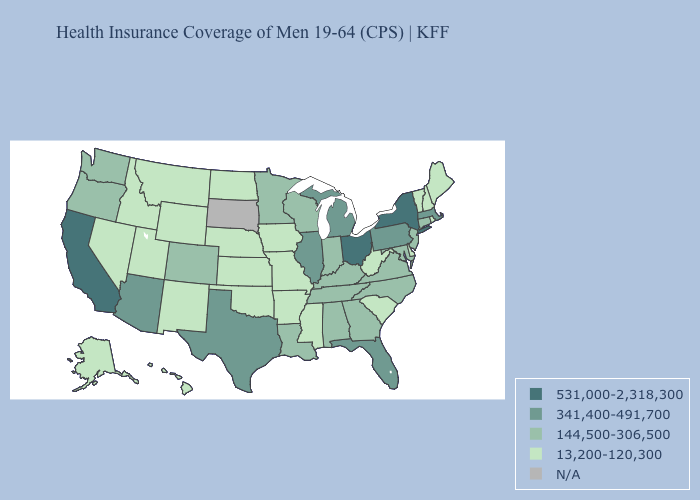What is the value of Illinois?
Write a very short answer. 341,400-491,700. Does Michigan have the lowest value in the MidWest?
Give a very brief answer. No. What is the value of Tennessee?
Write a very short answer. 144,500-306,500. What is the highest value in the South ?
Short answer required. 341,400-491,700. What is the lowest value in states that border Oklahoma?
Answer briefly. 13,200-120,300. Name the states that have a value in the range 144,500-306,500?
Give a very brief answer. Alabama, Colorado, Connecticut, Georgia, Indiana, Kentucky, Louisiana, Maryland, Minnesota, New Jersey, North Carolina, Oregon, Tennessee, Virginia, Washington, Wisconsin. What is the value of Kentucky?
Short answer required. 144,500-306,500. What is the highest value in the West ?
Concise answer only. 531,000-2,318,300. What is the value of Alabama?
Short answer required. 144,500-306,500. Does Kansas have the highest value in the MidWest?
Concise answer only. No. Name the states that have a value in the range 13,200-120,300?
Answer briefly. Alaska, Arkansas, Delaware, Hawaii, Idaho, Iowa, Kansas, Maine, Mississippi, Missouri, Montana, Nebraska, Nevada, New Hampshire, New Mexico, North Dakota, Oklahoma, Rhode Island, South Carolina, Utah, Vermont, West Virginia, Wyoming. Which states have the lowest value in the West?
Write a very short answer. Alaska, Hawaii, Idaho, Montana, Nevada, New Mexico, Utah, Wyoming. Which states have the lowest value in the USA?
Give a very brief answer. Alaska, Arkansas, Delaware, Hawaii, Idaho, Iowa, Kansas, Maine, Mississippi, Missouri, Montana, Nebraska, Nevada, New Hampshire, New Mexico, North Dakota, Oklahoma, Rhode Island, South Carolina, Utah, Vermont, West Virginia, Wyoming. What is the value of South Dakota?
Quick response, please. N/A. What is the value of West Virginia?
Give a very brief answer. 13,200-120,300. 